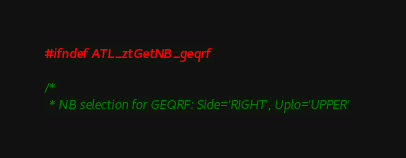<code> <loc_0><loc_0><loc_500><loc_500><_C_>#ifndef ATL_ztGetNB_geqrf

/*
 * NB selection for GEQRF: Side='RIGHT', Uplo='UPPER'</code> 